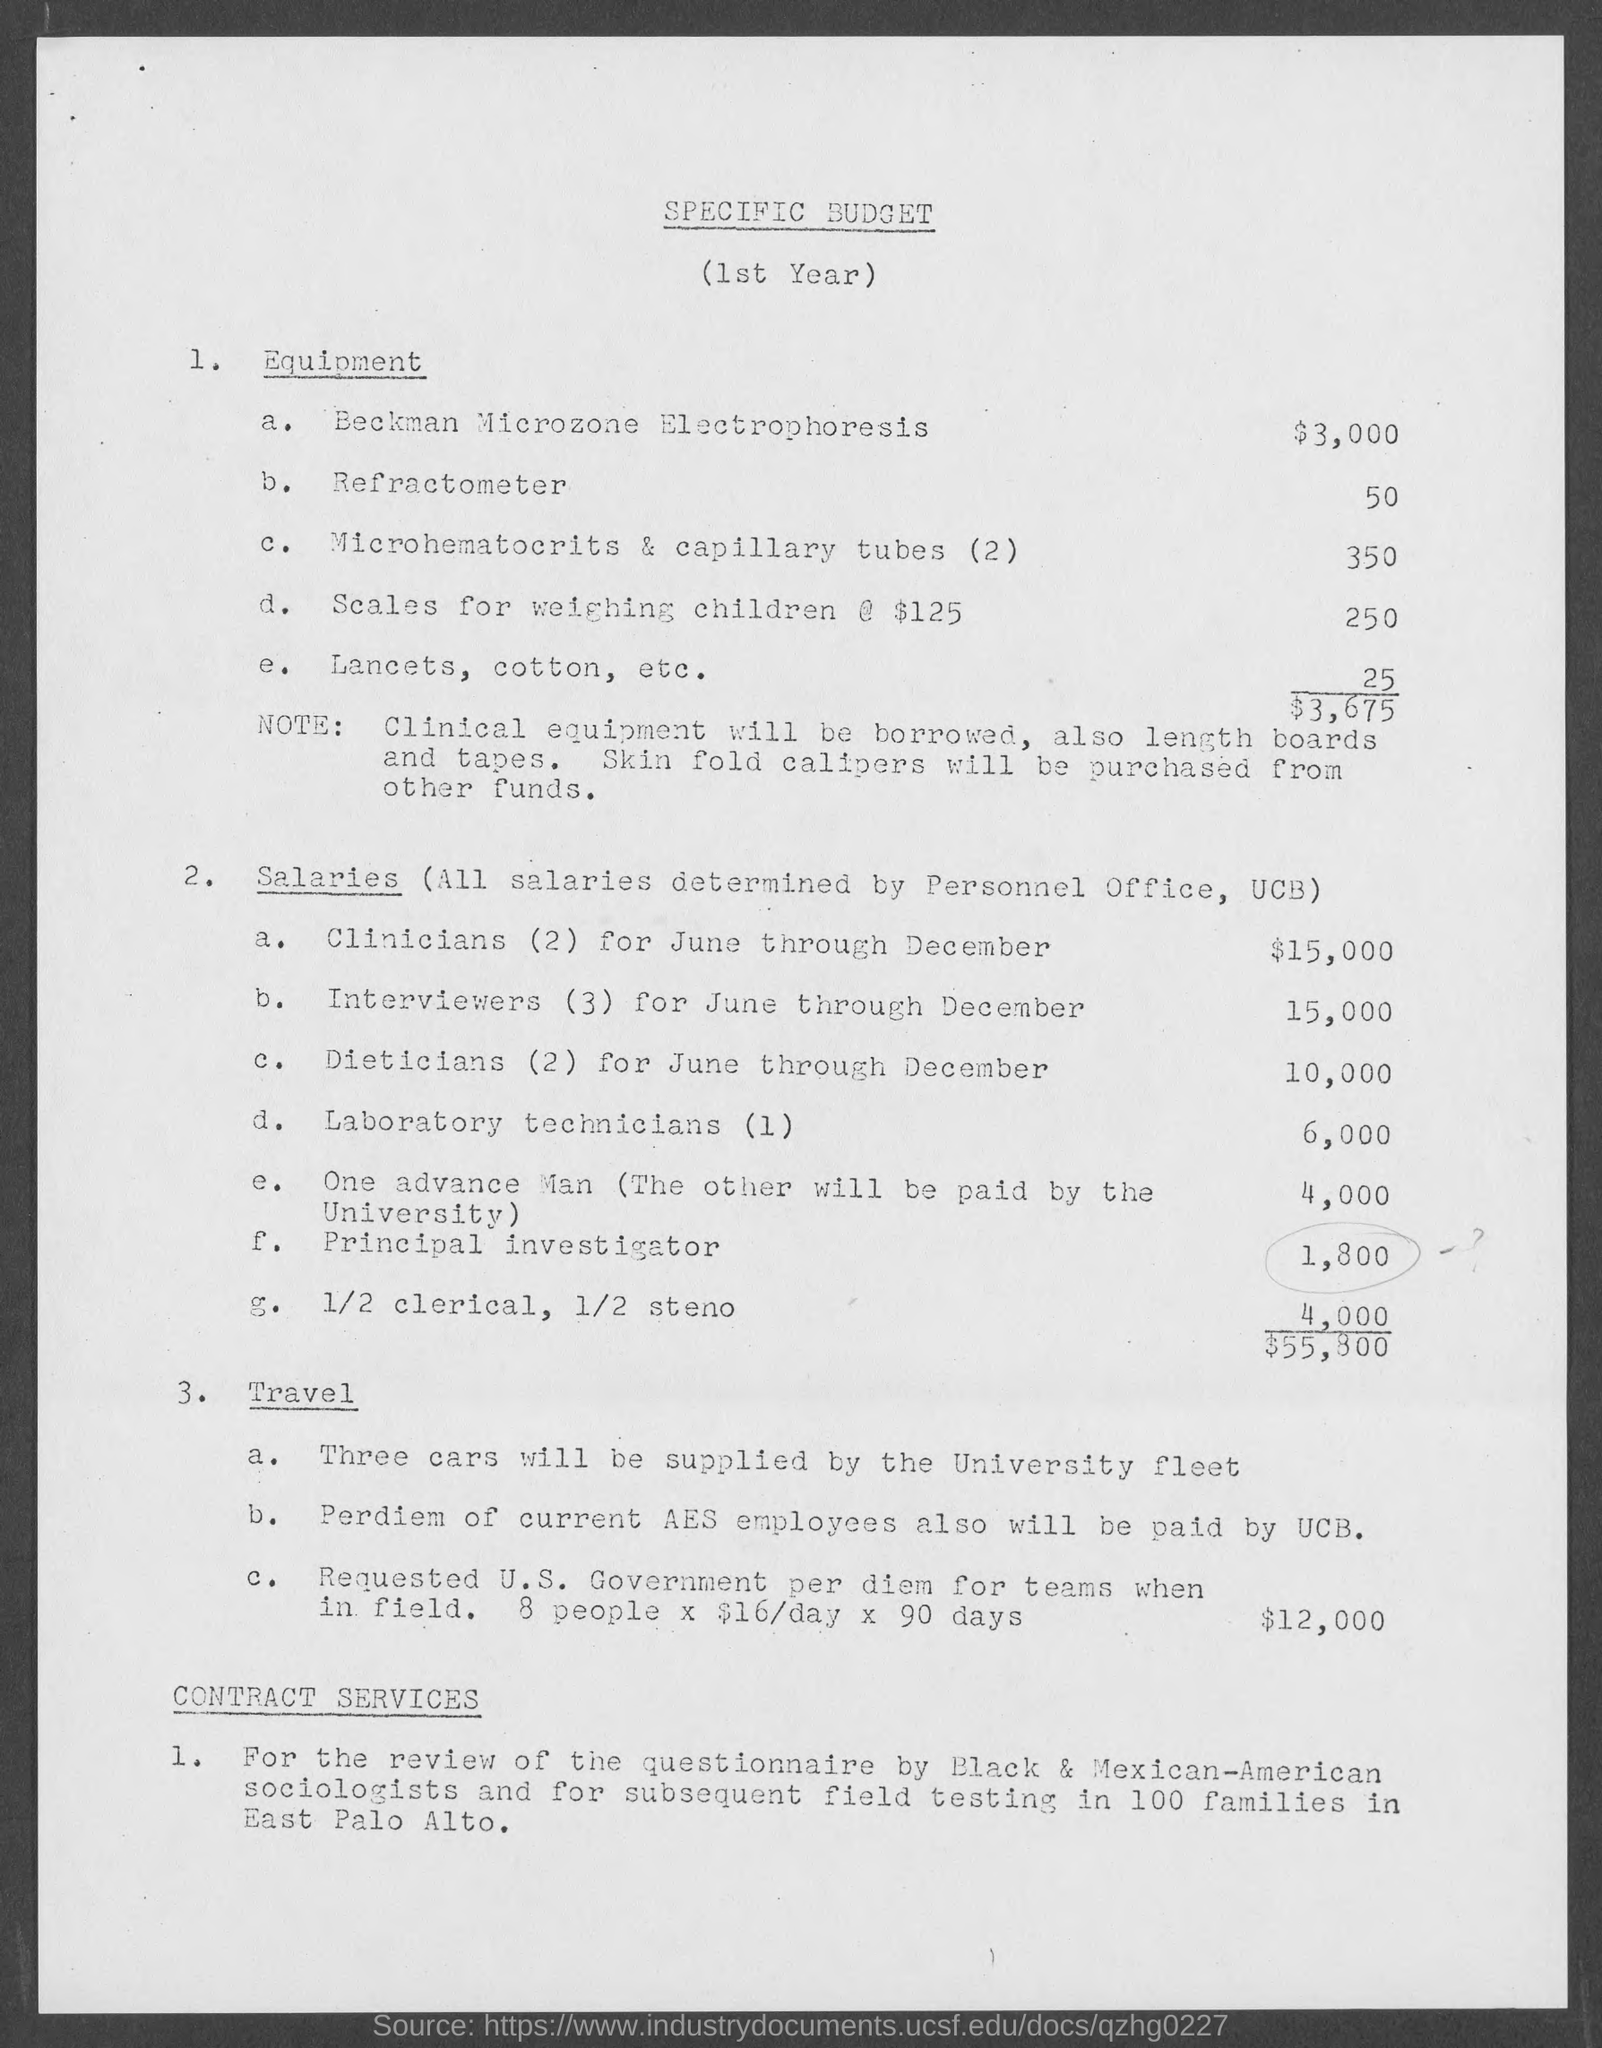Draw attention to some important aspects in this diagram. The cost for refractometer ranges from 50.. The cost for scales for weighing children is 250. The document's title is specific to the budget. The cost for a Beckman Microzone Electrophoresis system is approximately $3,000. The cost for microhematocrits and capillary tubes (2) is 350. 